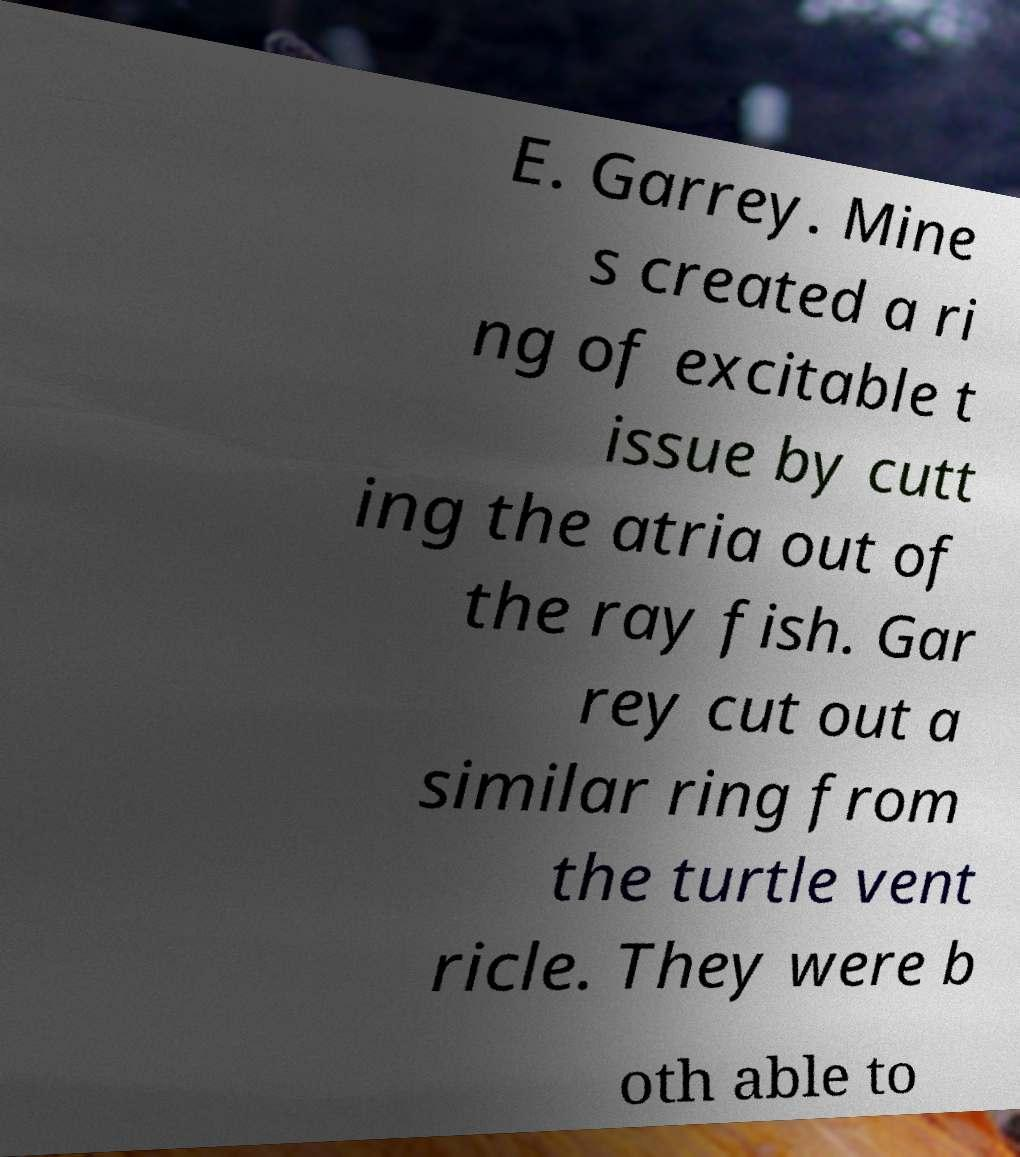Could you extract and type out the text from this image? E. Garrey. Mine s created a ri ng of excitable t issue by cutt ing the atria out of the ray fish. Gar rey cut out a similar ring from the turtle vent ricle. They were b oth able to 